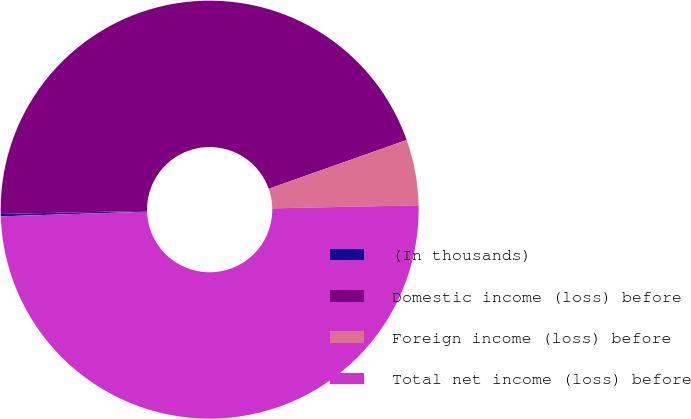<chart> <loc_0><loc_0><loc_500><loc_500><pie_chart><fcel>(In thousands)<fcel>Domestic income (loss) before<fcel>Foreign income (loss) before<fcel>Total net income (loss) before<nl><fcel>0.18%<fcel>44.92%<fcel>5.08%<fcel>49.82%<nl></chart> 